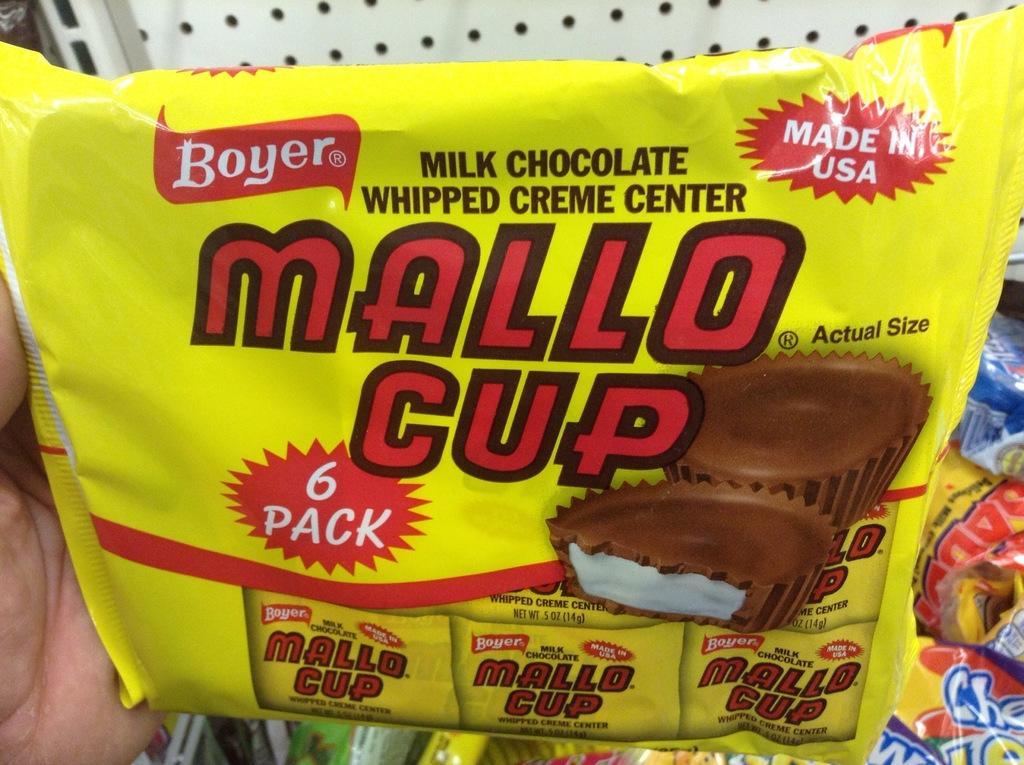Could you give a brief overview of what you see in this image? In this image we can see hand of a person with a packet. On the packet there is text. Also we can see images of cupcakes. In the background there are other packets. And there is a wall with holes. 